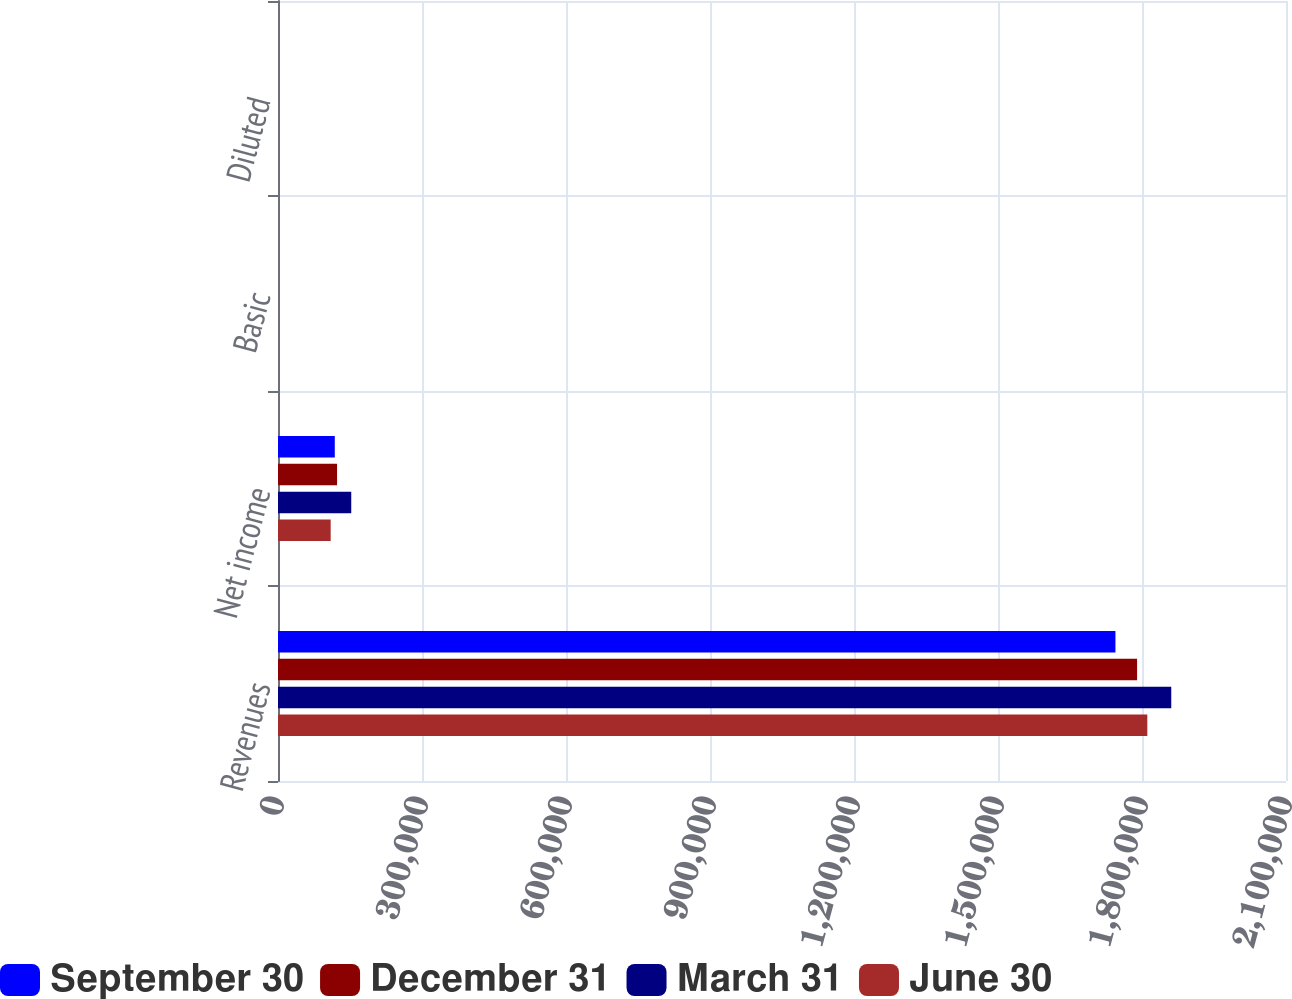<chart> <loc_0><loc_0><loc_500><loc_500><stacked_bar_chart><ecel><fcel>Revenues<fcel>Net income<fcel>Basic<fcel>Diluted<nl><fcel>September 30<fcel>1.74468e+06<fcel>118307<fcel>0.94<fcel>0.89<nl><fcel>December 31<fcel>1.78976e+06<fcel>123035<fcel>0.99<fcel>0.95<nl><fcel>March 31<fcel>1.86096e+06<fcel>152607<fcel>1.24<fcel>1.18<nl><fcel>June 30<fcel>1.81106e+06<fcel>109745<fcel>0.89<fcel>0.85<nl></chart> 